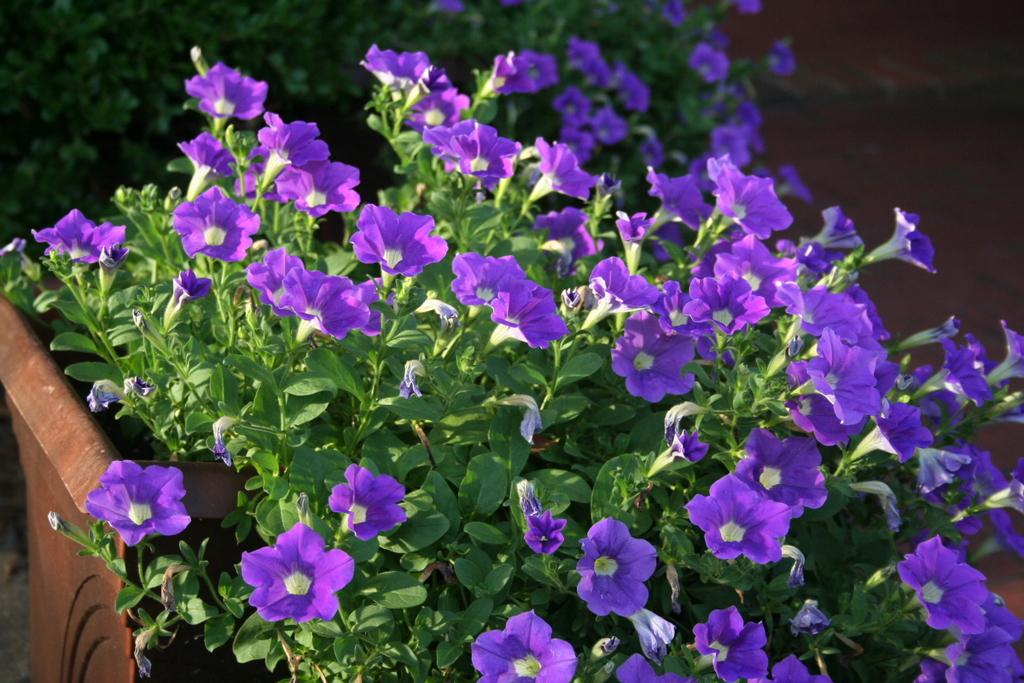What type of flowers can be seen in the image? There are purple color flowers in the image. What are the flowers placed in? There are flower pots in the image. What else can be seen in the image besides the flowers? There are plants in the image. Can you see a kitten folding its hands in the image? There is no kitten or any folding of hands present in the image. 